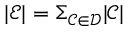<formula> <loc_0><loc_0><loc_500><loc_500>| \mathcal { E } | = \Sigma _ { \mathcal { C } \in \mathcal { D } } | \mathcal { C } |</formula> 